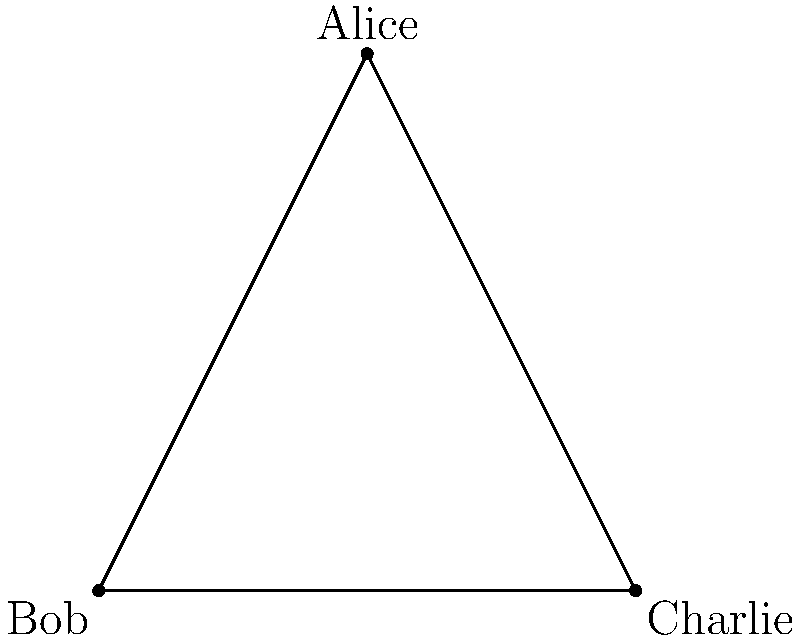In your latest romantic screenplay, you've crafted a love triangle between Alice, Bob, and Charlie. The graph above represents their relationships. If we remove one character (vertex) from this love triangle, how many edges would remain in the graph? To solve this problem, let's approach it step-by-step:

1. First, observe the initial graph:
   - It has 3 vertices (Alice, Bob, and Charlie)
   - It has 3 edges (Alice-Bob, Bob-Charlie, Charlie-Alice)

2. When we remove one character (vertex), we need to consider what happens to the edges:
   - Any edge connected to the removed vertex will also be removed
   - Each vertex is connected to two other vertices

3. Let's consider removing each character:
   - If we remove Alice: We lose the Alice-Bob and Alice-Charlie edges
   - If we remove Bob: We lose the Alice-Bob and Bob-Charlie edges
   - If we remove Charlie: We lose the Charlie-Alice and Bob-Charlie edges

4. In each case, we're left with only one edge:
   - Removing Alice leaves the Bob-Charlie edge
   - Removing Bob leaves the Alice-Charlie edge
   - Removing Charlie leaves the Alice-Bob edge

5. Therefore, regardless of which character we remove, we're always left with 1 edge.

This concept in graph theory demonstrates how the removal of a vertex affects the connectivity of the remaining graph, which can be analogous to how the removal of a character might affect the dynamics in a romantic narrative.
Answer: 1 edge 